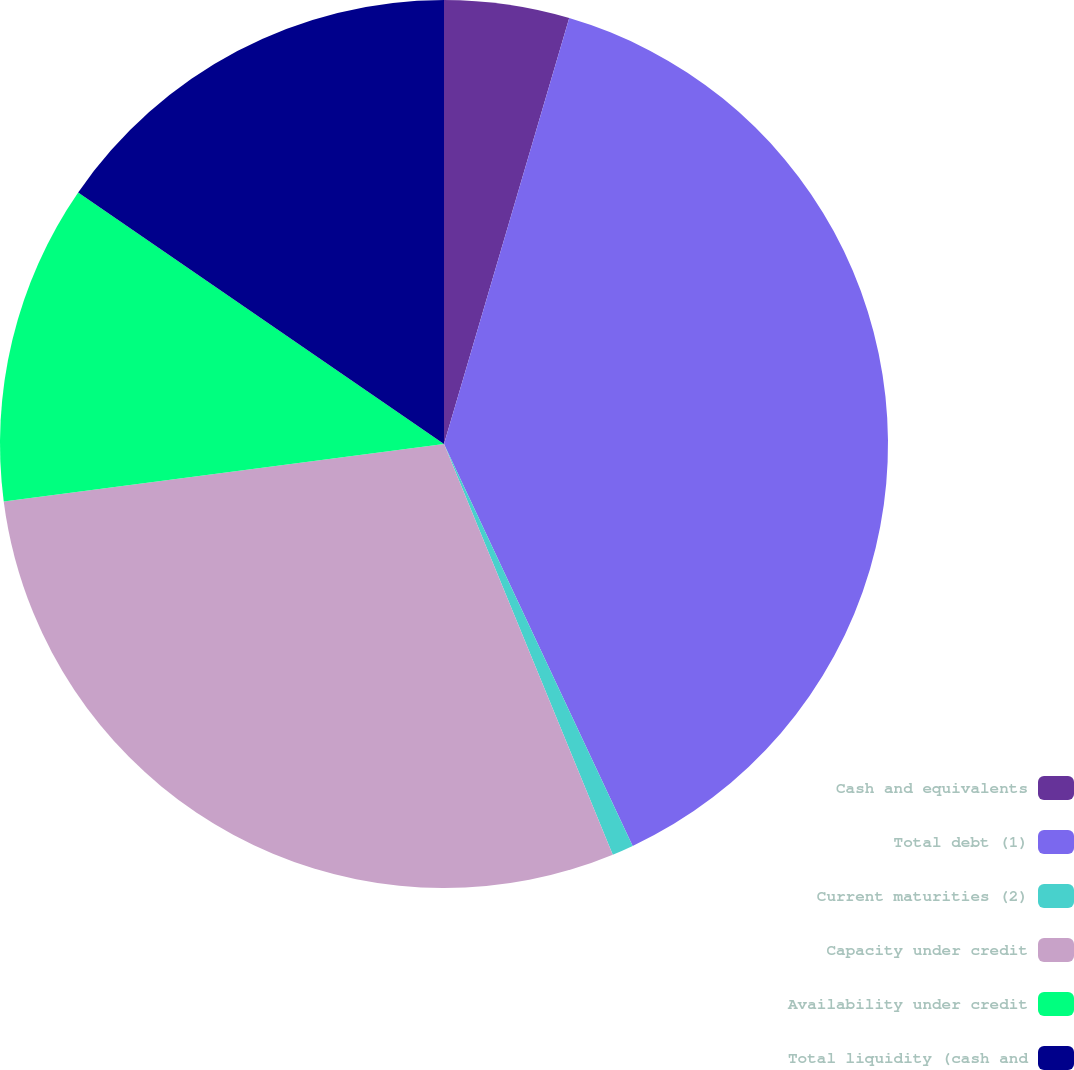<chart> <loc_0><loc_0><loc_500><loc_500><pie_chart><fcel>Cash and equivalents<fcel>Total debt (1)<fcel>Current maturities (2)<fcel>Capacity under credit<fcel>Availability under credit<fcel>Total liquidity (cash and<nl><fcel>4.55%<fcel>38.46%<fcel>0.78%<fcel>29.14%<fcel>11.65%<fcel>15.41%<nl></chart> 